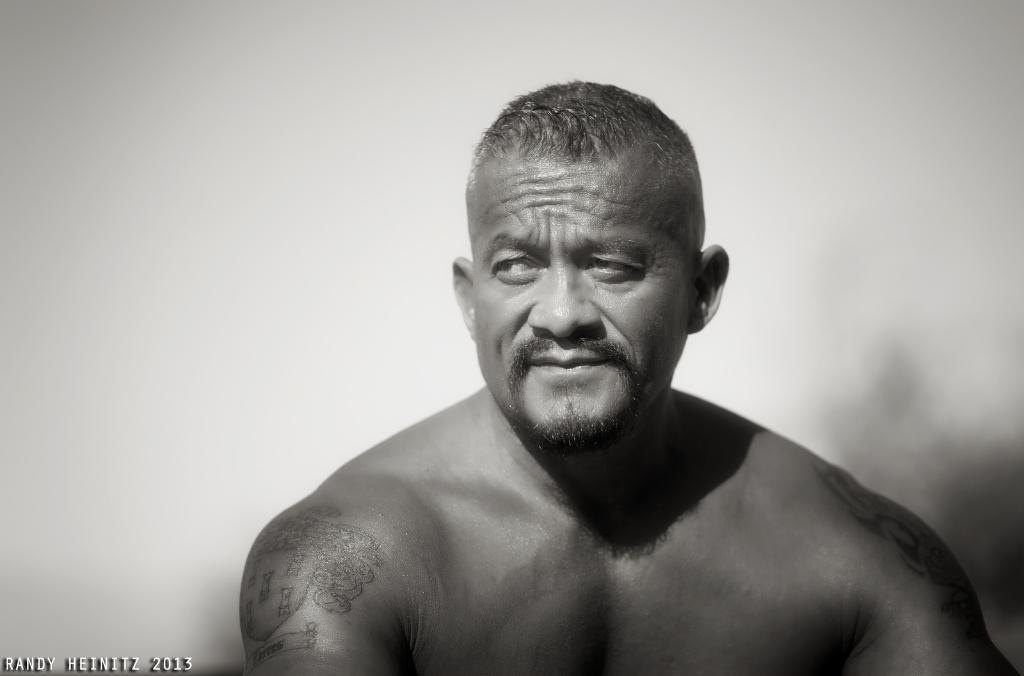What is the color scheme of the image? The image is black and white. Who is present in the image? There is a man in the image. In which direction is the man looking? The man is looking to the left. Can you describe the background of the image? The background of the image is blurred. Where is the text located in the image? The text is in the bottom left-hand corner of the image. What type of beef is being served in the image? There is no beef present in the image; it is a black and white image of a man looking to the left with a blurred background and text in the bottom left-hand corner. How many jellyfish can be seen in the image? There are no jellyfish present in the image. 